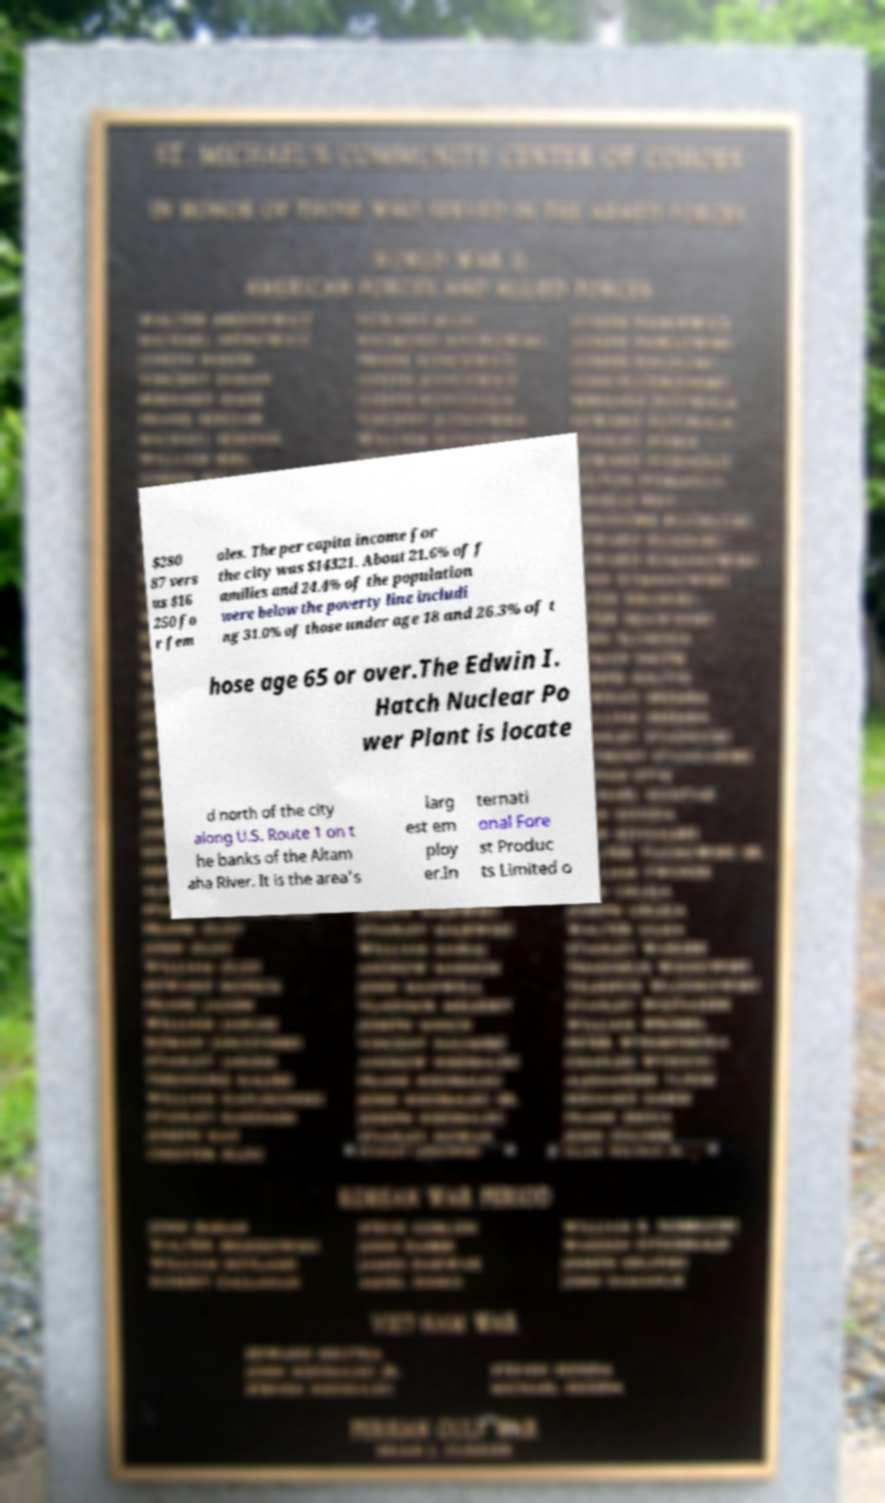Could you assist in decoding the text presented in this image and type it out clearly? $280 87 vers us $16 250 fo r fem ales. The per capita income for the city was $14321. About 21.6% of f amilies and 24.4% of the population were below the poverty line includi ng 31.0% of those under age 18 and 26.3% of t hose age 65 or over.The Edwin I. Hatch Nuclear Po wer Plant is locate d north of the city along U.S. Route 1 on t he banks of the Altam aha River. It is the area's larg est em ploy er.In ternati onal Fore st Produc ts Limited o 